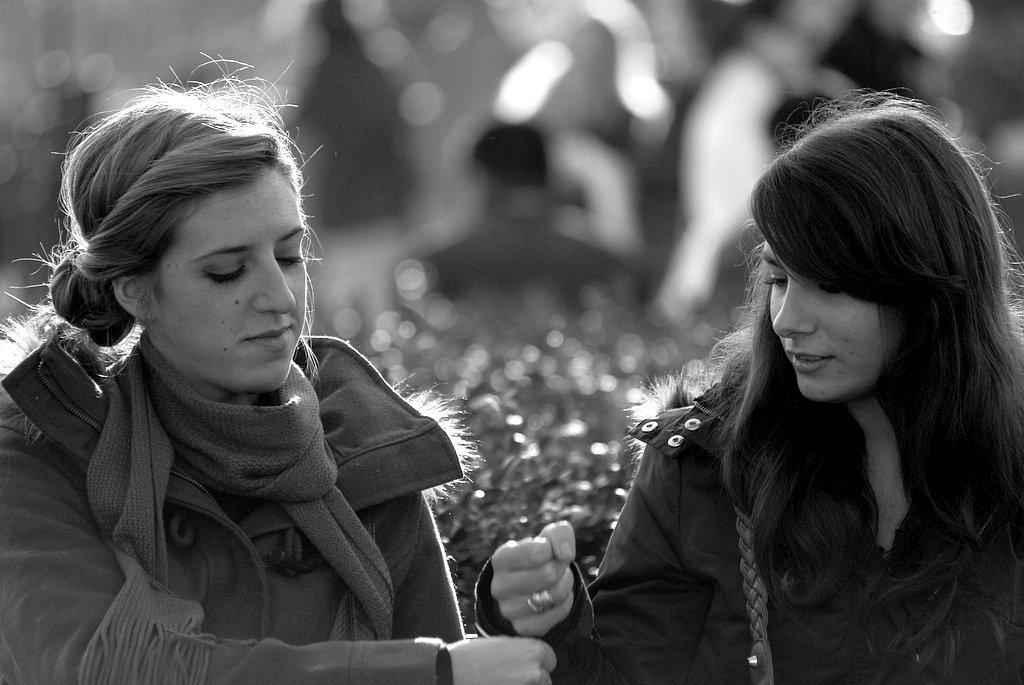What is the color scheme of the image? The image is black and white. How many people are in the image? There are two women in the image. What is the second woman doing in the image? The second woman is tying something to the person beside her. Can you describe the background of the image? The background of the image is blurred. What type of meat is being cooked in the oven in the image? There is no oven or meat present in the image. How many fingers does the first woman have on her left hand in the image? The image is black and white, and it is not possible to determine the number of fingers on the first woman's left hand. 